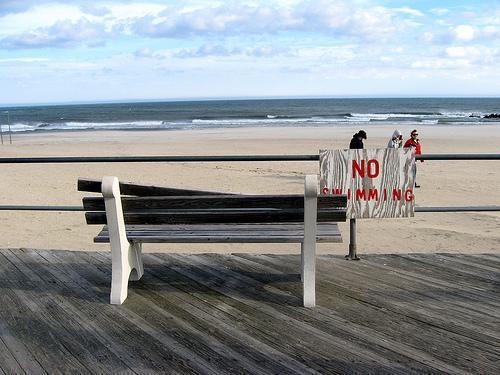How many benches?
Give a very brief answer. 1. How many people?
Give a very brief answer. 3. 